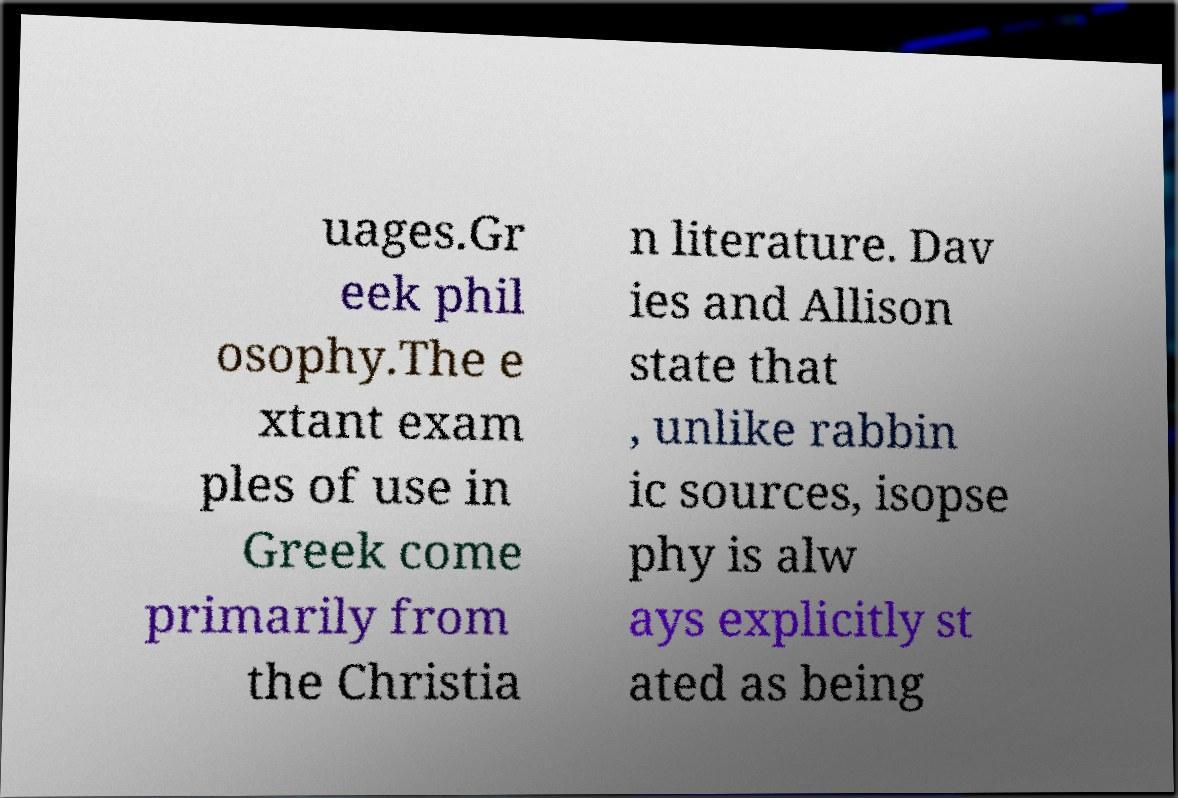What messages or text are displayed in this image? I need them in a readable, typed format. uages.Gr eek phil osophy.The e xtant exam ples of use in Greek come primarily from the Christia n literature. Dav ies and Allison state that , unlike rabbin ic sources, isopse phy is alw ays explicitly st ated as being 